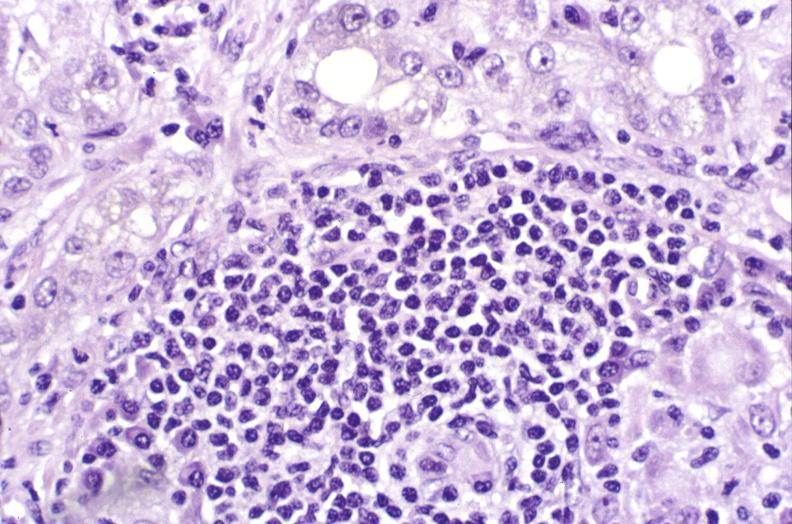what is present?
Answer the question using a single word or phrase. Liver 